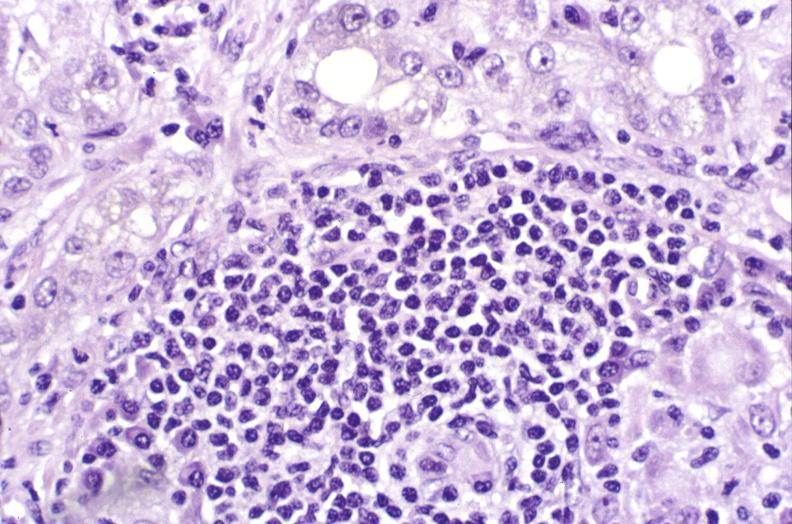what is present?
Answer the question using a single word or phrase. Liver 